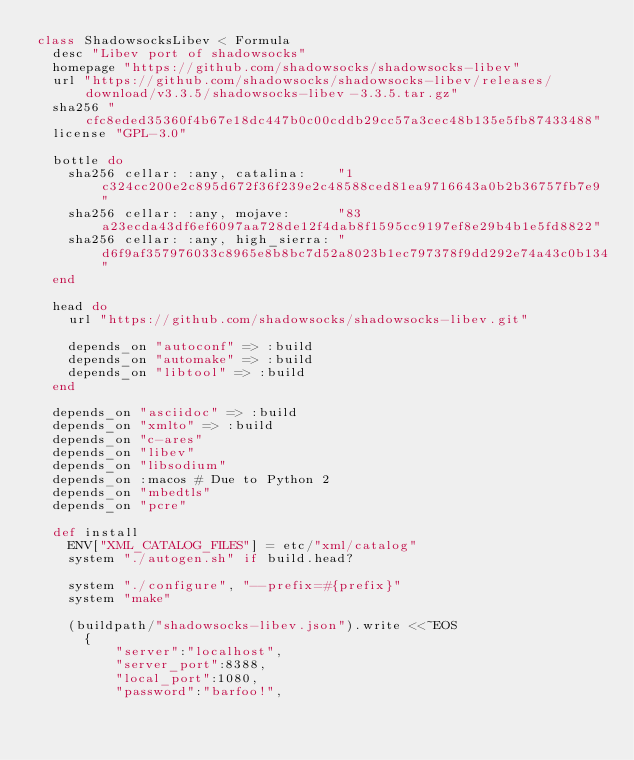Convert code to text. <code><loc_0><loc_0><loc_500><loc_500><_Ruby_>class ShadowsocksLibev < Formula
  desc "Libev port of shadowsocks"
  homepage "https://github.com/shadowsocks/shadowsocks-libev"
  url "https://github.com/shadowsocks/shadowsocks-libev/releases/download/v3.3.5/shadowsocks-libev-3.3.5.tar.gz"
  sha256 "cfc8eded35360f4b67e18dc447b0c00cddb29cc57a3cec48b135e5fb87433488"
  license "GPL-3.0"

  bottle do
    sha256 cellar: :any, catalina:    "1c324cc200e2c895d672f36f239e2c48588ced81ea9716643a0b2b36757fb7e9"
    sha256 cellar: :any, mojave:      "83a23ecda43df6ef6097aa728de12f4dab8f1595cc9197ef8e29b4b1e5fd8822"
    sha256 cellar: :any, high_sierra: "d6f9af357976033c8965e8b8bc7d52a8023b1ec797378f9dd292e74a43c0b134"
  end

  head do
    url "https://github.com/shadowsocks/shadowsocks-libev.git"

    depends_on "autoconf" => :build
    depends_on "automake" => :build
    depends_on "libtool" => :build
  end

  depends_on "asciidoc" => :build
  depends_on "xmlto" => :build
  depends_on "c-ares"
  depends_on "libev"
  depends_on "libsodium"
  depends_on :macos # Due to Python 2
  depends_on "mbedtls"
  depends_on "pcre"

  def install
    ENV["XML_CATALOG_FILES"] = etc/"xml/catalog"
    system "./autogen.sh" if build.head?

    system "./configure", "--prefix=#{prefix}"
    system "make"

    (buildpath/"shadowsocks-libev.json").write <<~EOS
      {
          "server":"localhost",
          "server_port":8388,
          "local_port":1080,
          "password":"barfoo!",</code> 